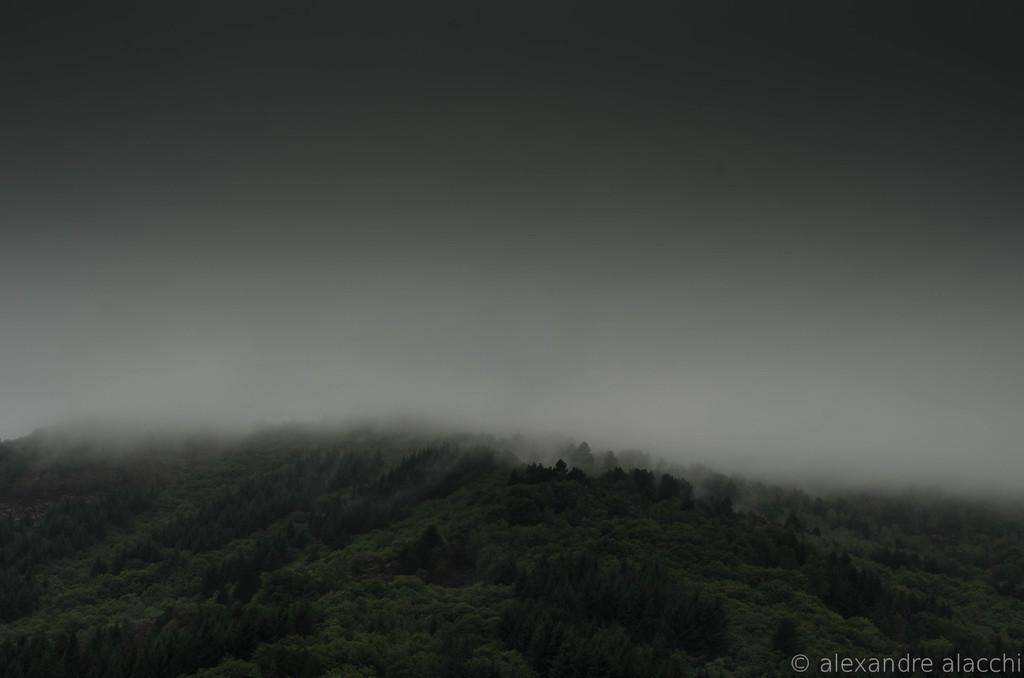What type of vegetation is present at the bottom of the image? There are trees at the bottom of the image. What part of the natural environment is visible in the background of the image? The sky is visible in the background of the image. How is the background of the image affected by weather conditions? The background of the image is covered with fog. Where is the stove located in the image? There is no stove present in the image. What type of patch can be seen on the trees in the image? There are no patches visible on the trees in the image. 